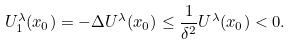Convert formula to latex. <formula><loc_0><loc_0><loc_500><loc_500>U ^ { \lambda } _ { 1 } ( x _ { 0 } ) = - \Delta U ^ { \lambda } ( x _ { 0 } ) \leq \frac { 1 } { \delta ^ { 2 } } U ^ { \lambda } ( x _ { 0 } ) < 0 .</formula> 